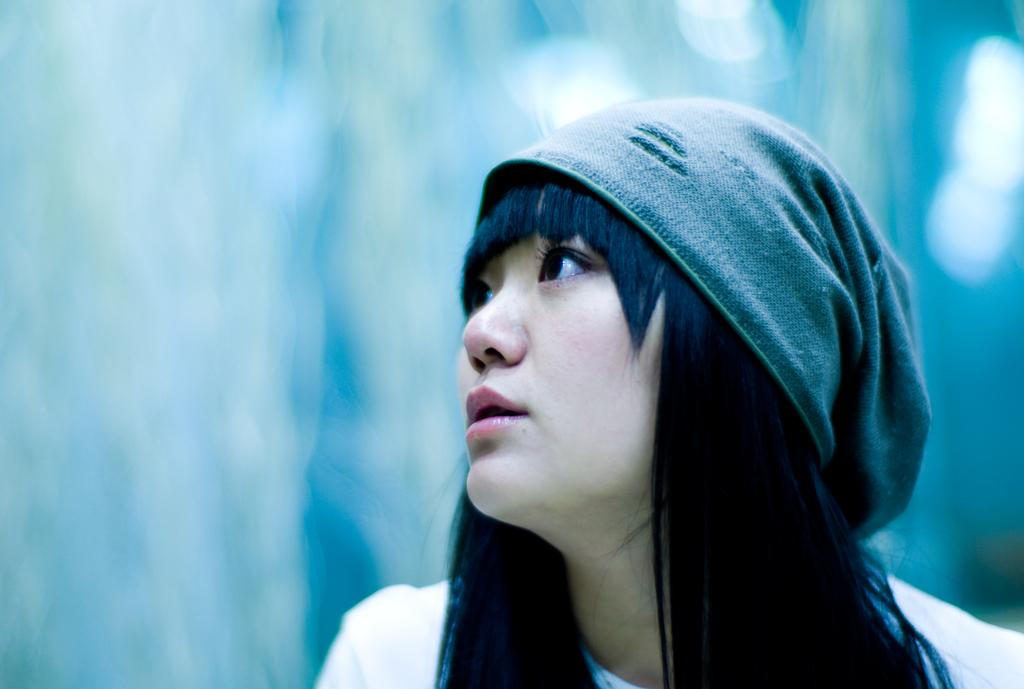Who is the main subject in the image? There is a woman in the image. What is the woman wearing on her head? The woman is wearing a cap. What type of clothing is the woman wearing on her upper body? The woman is wearing a white t-shirt. Can you describe the background of the image? There is a blurred image in the background of the image. How many icicles are hanging from the woman's cap in the image? There are no icicles present in the image. What type of zipper can be seen on the woman's t-shirt in the image? There is no zipper visible on the woman's t-shirt in the image. 